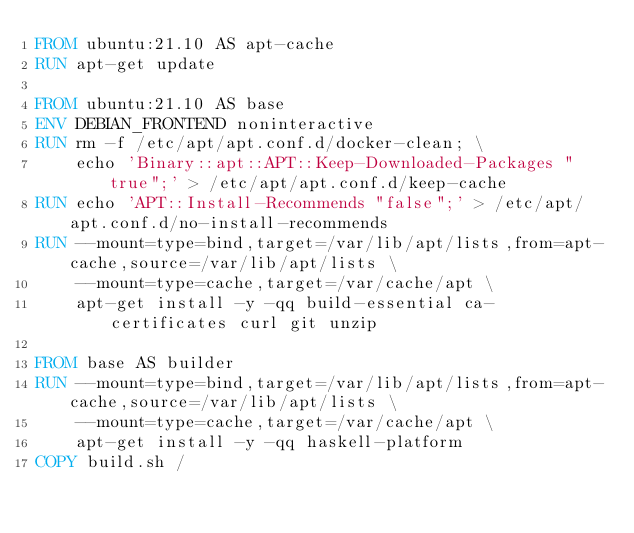<code> <loc_0><loc_0><loc_500><loc_500><_Dockerfile_>FROM ubuntu:21.10 AS apt-cache
RUN apt-get update

FROM ubuntu:21.10 AS base
ENV DEBIAN_FRONTEND noninteractive
RUN rm -f /etc/apt/apt.conf.d/docker-clean; \
    echo 'Binary::apt::APT::Keep-Downloaded-Packages "true";' > /etc/apt/apt.conf.d/keep-cache
RUN echo 'APT::Install-Recommends "false";' > /etc/apt/apt.conf.d/no-install-recommends
RUN --mount=type=bind,target=/var/lib/apt/lists,from=apt-cache,source=/var/lib/apt/lists \
    --mount=type=cache,target=/var/cache/apt \
    apt-get install -y -qq build-essential ca-certificates curl git unzip

FROM base AS builder
RUN --mount=type=bind,target=/var/lib/apt/lists,from=apt-cache,source=/var/lib/apt/lists \
    --mount=type=cache,target=/var/cache/apt \
    apt-get install -y -qq haskell-platform
COPY build.sh /
</code> 